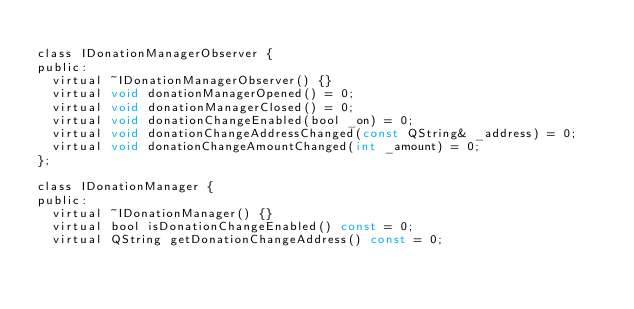Convert code to text. <code><loc_0><loc_0><loc_500><loc_500><_C_>
class IDonationManagerObserver {
public:
  virtual ~IDonationManagerObserver() {}
  virtual void donationManagerOpened() = 0;
  virtual void donationManagerClosed() = 0;
  virtual void donationChangeEnabled(bool _on) = 0;
  virtual void donationChangeAddressChanged(const QString& _address) = 0;
  virtual void donationChangeAmountChanged(int _amount) = 0;
};

class IDonationManager {
public:
  virtual ~IDonationManager() {}
  virtual bool isDonationChangeEnabled() const = 0;
  virtual QString getDonationChangeAddress() const = 0;</code> 